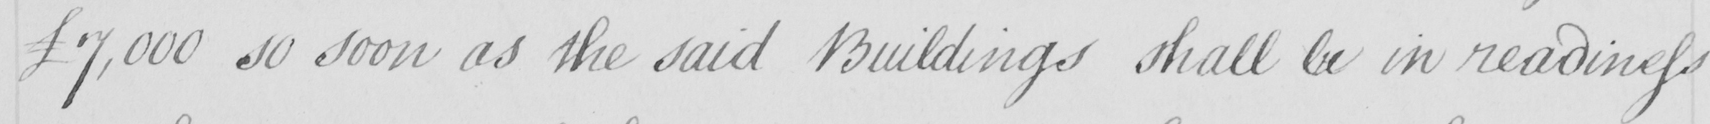Please provide the text content of this handwritten line. £7,000 so soon as the said Buildings shall be in readiness 